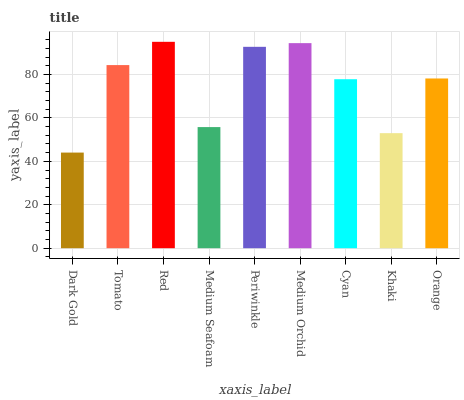Is Dark Gold the minimum?
Answer yes or no. Yes. Is Red the maximum?
Answer yes or no. Yes. Is Tomato the minimum?
Answer yes or no. No. Is Tomato the maximum?
Answer yes or no. No. Is Tomato greater than Dark Gold?
Answer yes or no. Yes. Is Dark Gold less than Tomato?
Answer yes or no. Yes. Is Dark Gold greater than Tomato?
Answer yes or no. No. Is Tomato less than Dark Gold?
Answer yes or no. No. Is Orange the high median?
Answer yes or no. Yes. Is Orange the low median?
Answer yes or no. Yes. Is Khaki the high median?
Answer yes or no. No. Is Periwinkle the low median?
Answer yes or no. No. 